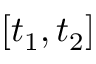<formula> <loc_0><loc_0><loc_500><loc_500>[ t _ { 1 } , t _ { 2 } ]</formula> 